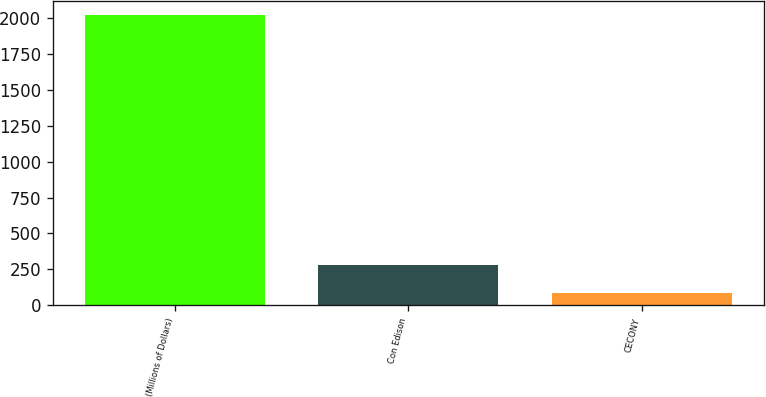<chart> <loc_0><loc_0><loc_500><loc_500><bar_chart><fcel>(Millions of Dollars)<fcel>Con Edison<fcel>CECONY<nl><fcel>2018<fcel>281<fcel>88<nl></chart> 